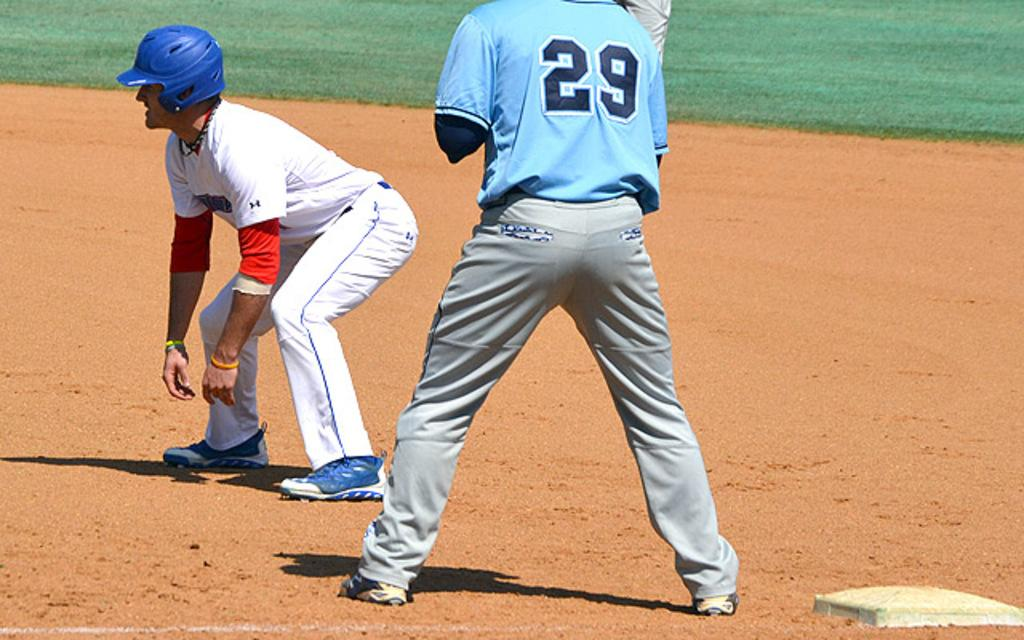How many people are present in the image? There are two persons standing in the image. What can be seen in the background of the image? There is grass visible in the background of the image. What type of rail can be seen in the image? There is no rail present in the image. Is it raining in the image? The image does not show any indication of rain. What type of rest can be seen in the image? There is no specific type of rest visible in the image; it simply features two persons standing. 